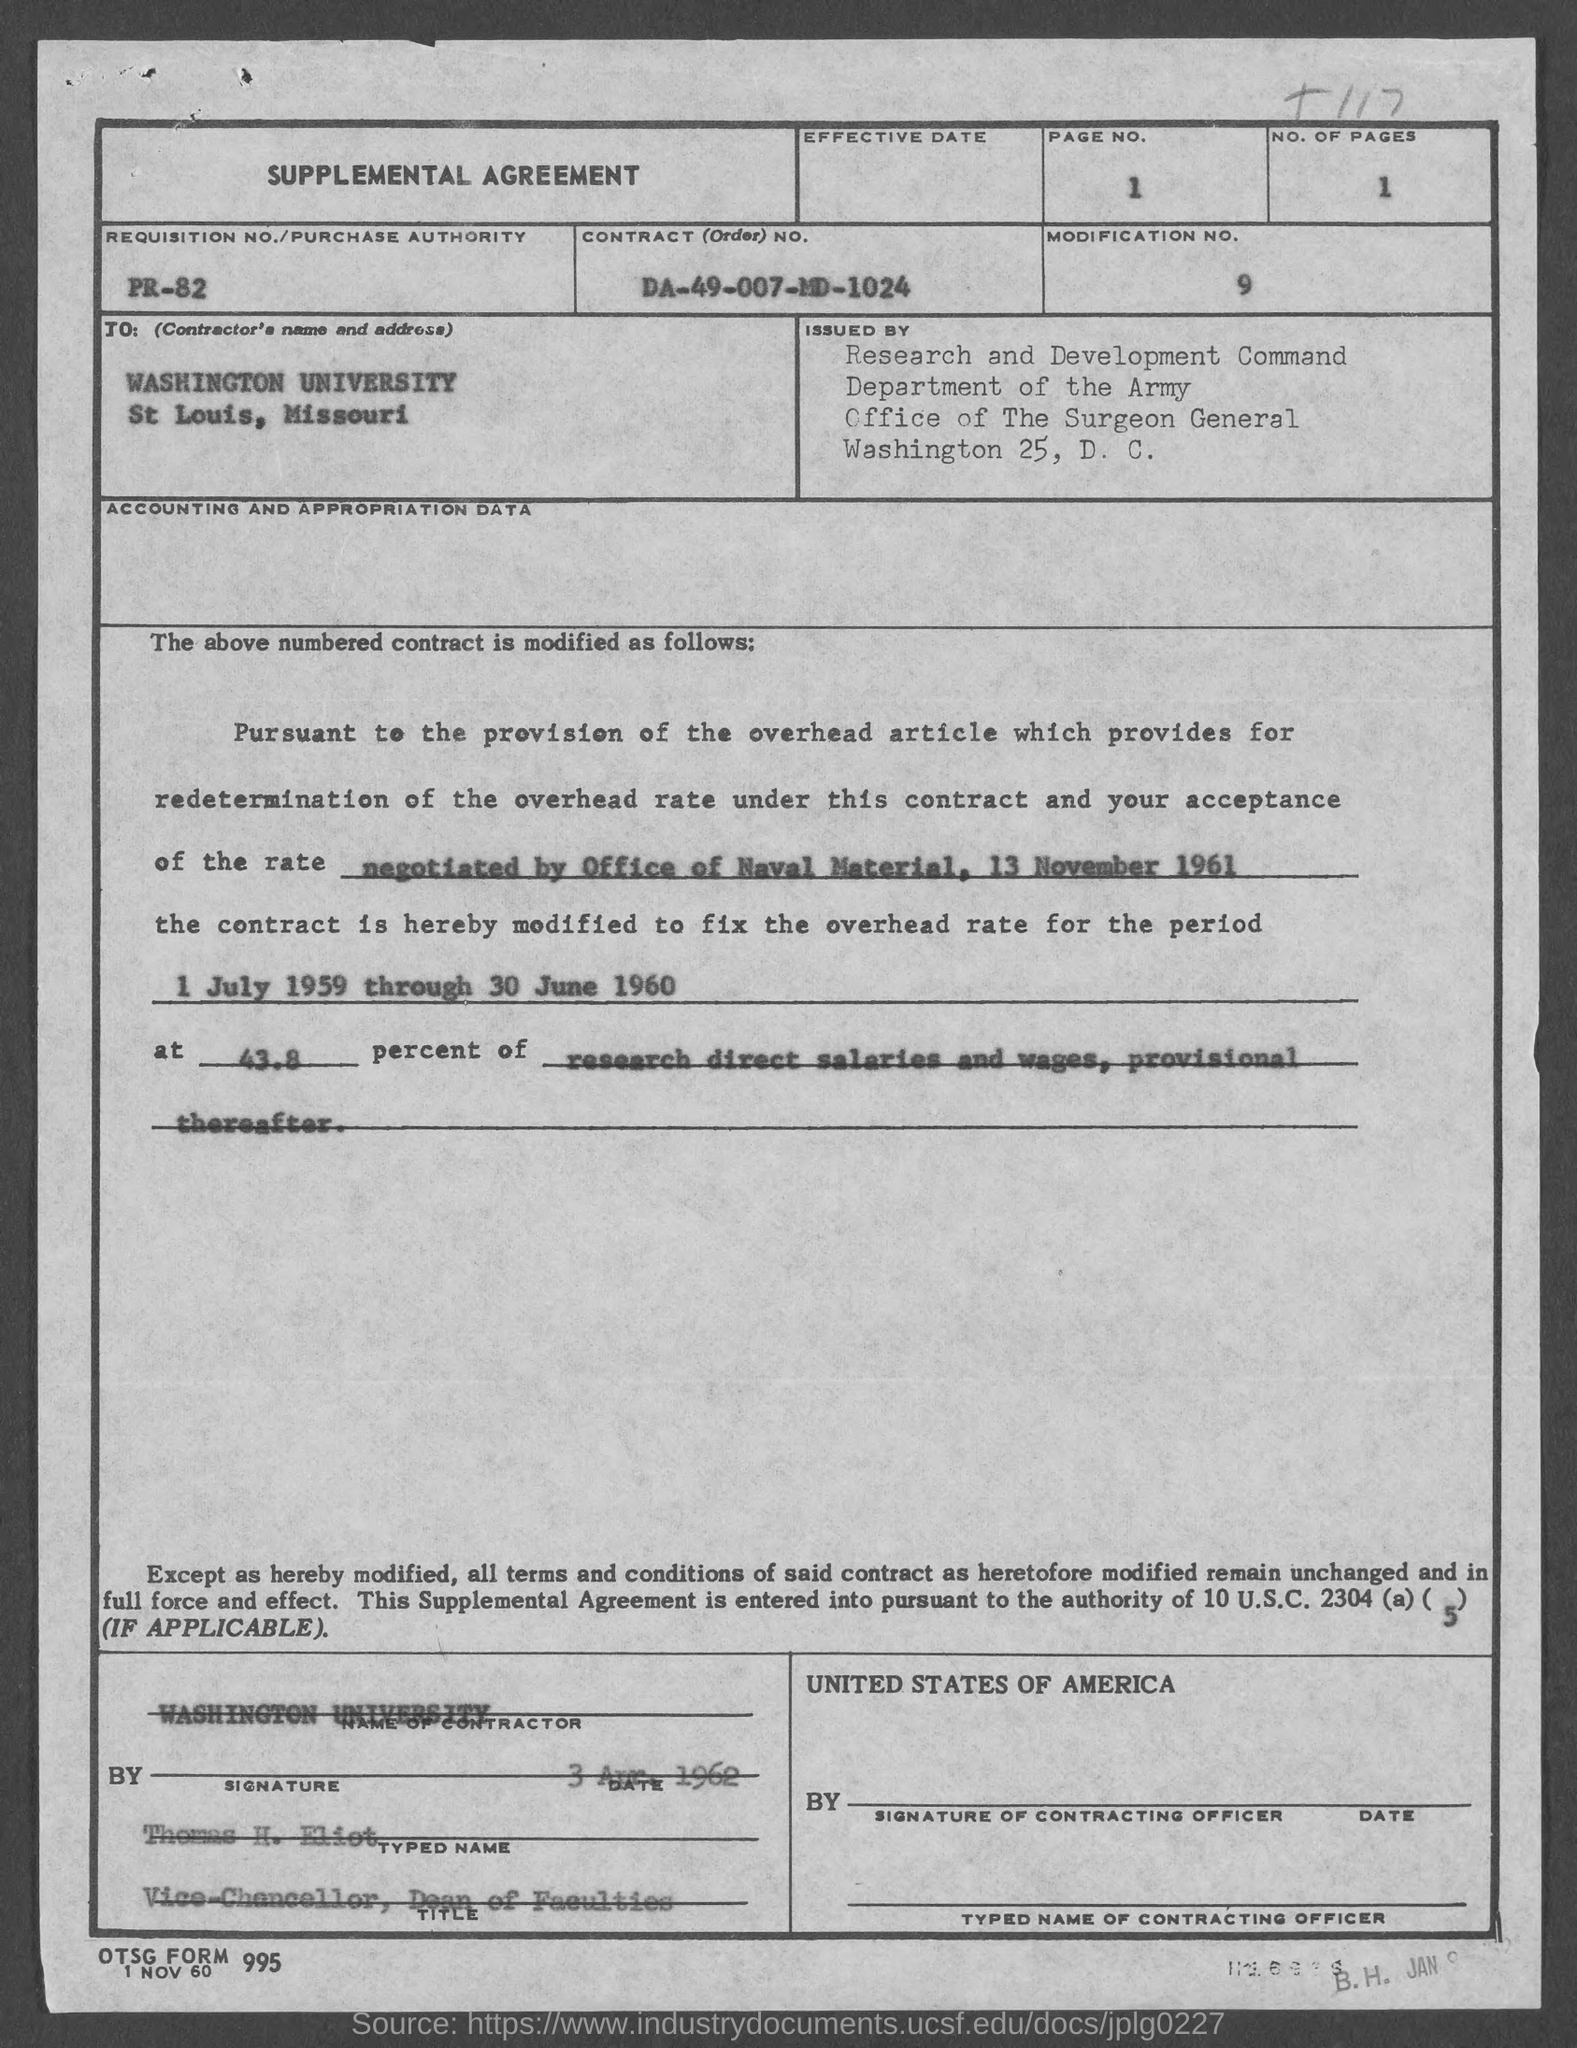Outline some significant characteristics in this image. The contract number is DA-49-007-MD-1024. What is the requisition number/purchase authority?" is a question asking for information about the specific details of a purchase proposal or request. Thomas H. Eliot holds the position of Vice-Chancellor. The contractor's name is Washington University. The page number is 1 and the range is 1.. 